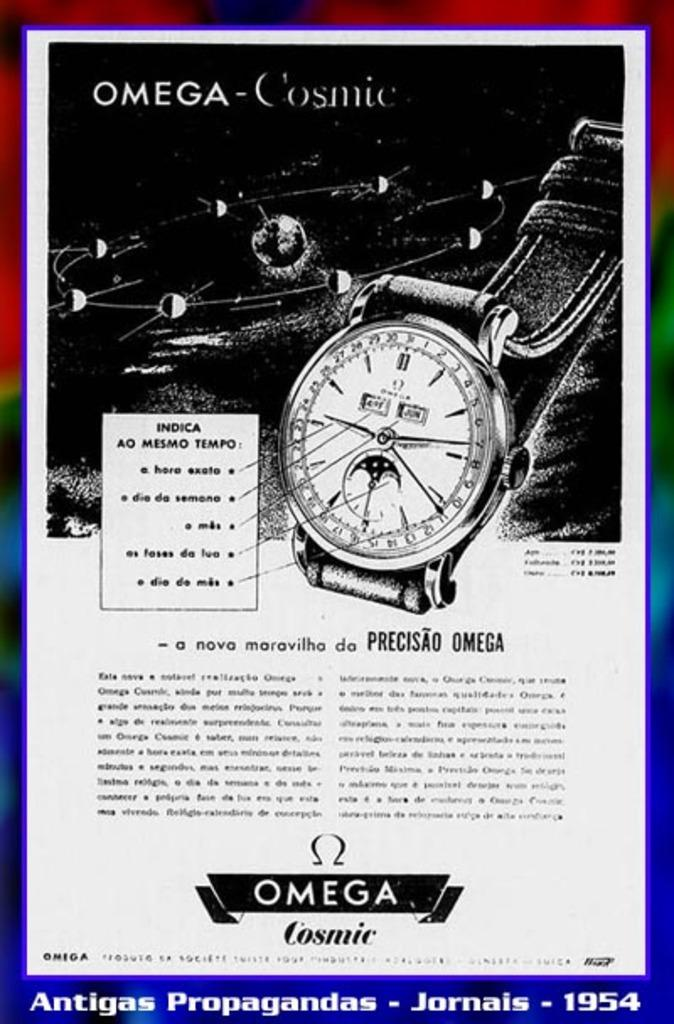<image>
Relay a brief, clear account of the picture shown. An ad for "OMEGA - Cosmic" is displaying a picture of a watch. 